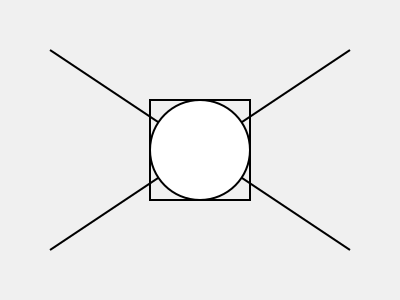Analyze the composition in the given image. Which element serves as the focal point, and how do the lines and shapes contribute to directing attention towards it? To identify the focal point and understand how lines and shapes contribute to it, let's analyze the composition step-by-step:

1. Identifying elements:
   - Two diagonal lines intersecting at the center
   - A circle in the center
   - A square surrounding the circle

2. Focal point:
   The circle at the center is the focal point of the composition. It stands out due to its position and contrast with other elements.

3. Contribution of lines:
   - The two diagonal lines intersect at the center, where the circle is located.
   - These lines create a strong directional flow, guiding the viewer's eye towards the center.
   - The lines form an "X" shape, emphasizing the importance of the central area.

4. Contribution of shapes:
   - The circle is the most prominent shape, positioned at the center of the composition.
   - The square surrounding the circle creates a frame, further emphasizing the central area.
   - The contrast between the curved circle and the straight lines of the square draws attention to the center.

5. Principles of composition:
   - Symmetry: The diagonal lines create a balanced, symmetrical composition.
   - Contrast: The circular shape contrasts with the straight lines and square, making it stand out.
   - Emphasis: The positioning and framing of the circle emphasize its importance as the focal point.

By using these elements and principles, the composition effectively directs the viewer's attention to the central circle, establishing it as the focal point of the design.
Answer: The circle at the center, emphasized by intersecting diagonal lines and a surrounding square. 